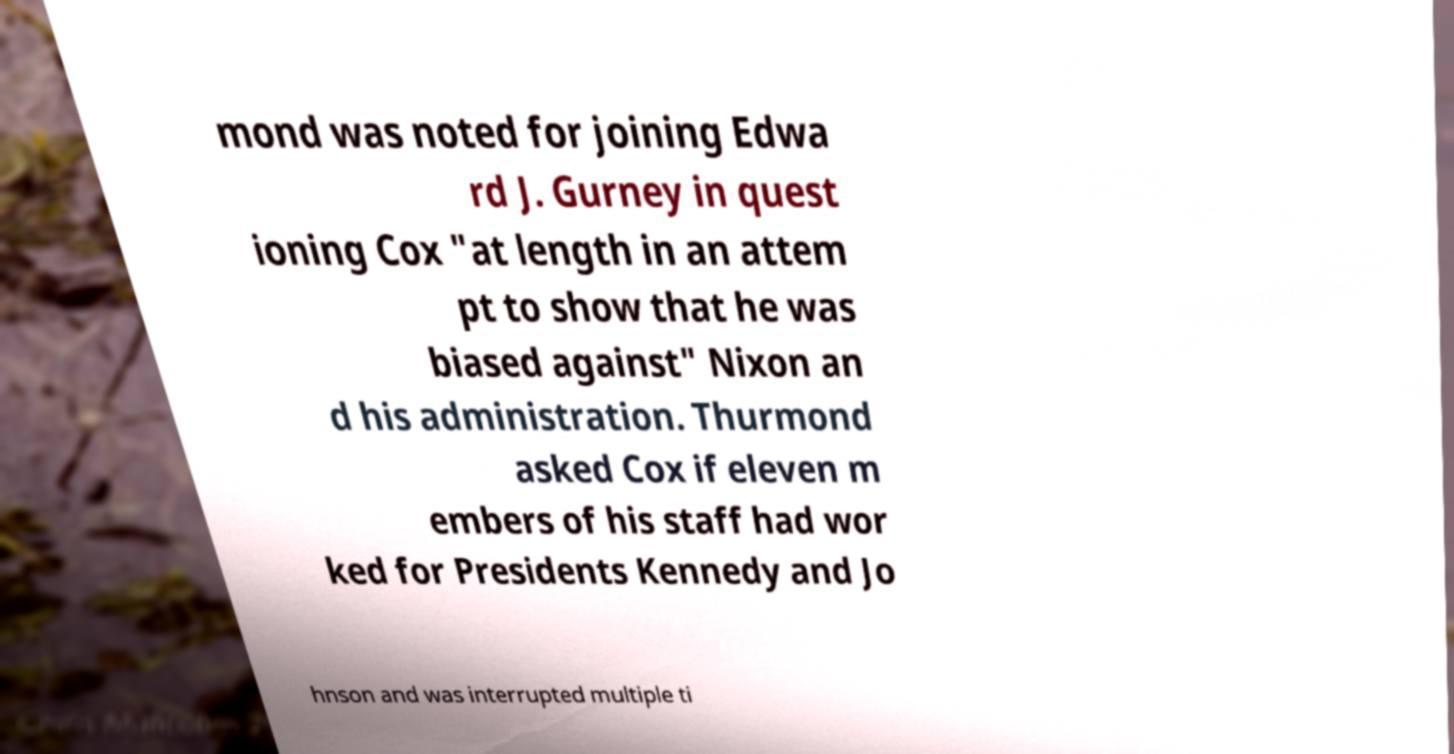Please identify and transcribe the text found in this image. mond was noted for joining Edwa rd J. Gurney in quest ioning Cox "at length in an attem pt to show that he was biased against" Nixon an d his administration. Thurmond asked Cox if eleven m embers of his staff had wor ked for Presidents Kennedy and Jo hnson and was interrupted multiple ti 